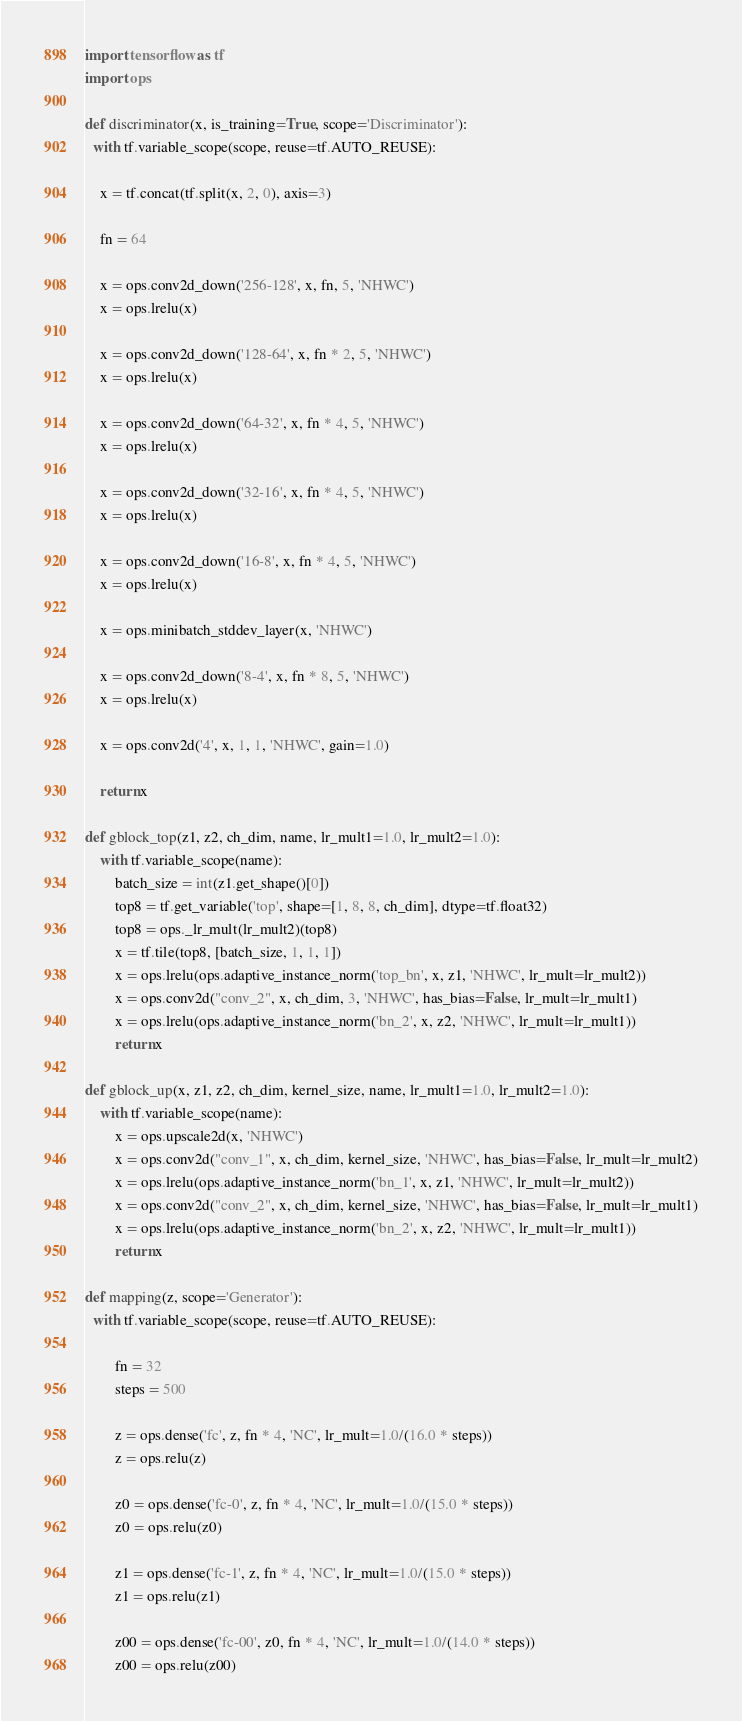Convert code to text. <code><loc_0><loc_0><loc_500><loc_500><_Python_>import tensorflow as tf
import ops

def discriminator(x, is_training=True, scope='Discriminator'):
  with tf.variable_scope(scope, reuse=tf.AUTO_REUSE):

    x = tf.concat(tf.split(x, 2, 0), axis=3)

    fn = 64    

    x = ops.conv2d_down('256-128', x, fn, 5, 'NHWC')
    x = ops.lrelu(x)

    x = ops.conv2d_down('128-64', x, fn * 2, 5, 'NHWC')
    x = ops.lrelu(x)

    x = ops.conv2d_down('64-32', x, fn * 4, 5, 'NHWC')
    x = ops.lrelu(x)

    x = ops.conv2d_down('32-16', x, fn * 4, 5, 'NHWC')
    x = ops.lrelu(x)

    x = ops.conv2d_down('16-8', x, fn * 4, 5, 'NHWC')
    x = ops.lrelu(x)
    
    x = ops.minibatch_stddev_layer(x, 'NHWC')

    x = ops.conv2d_down('8-4', x, fn * 8, 5, 'NHWC')
    x = ops.lrelu(x)

    x = ops.conv2d('4', x, 1, 1, 'NHWC', gain=1.0)

    return x

def gblock_top(z1, z2, ch_dim, name, lr_mult1=1.0, lr_mult2=1.0):
    with tf.variable_scope(name):
        batch_size = int(z1.get_shape()[0])
        top8 = tf.get_variable('top', shape=[1, 8, 8, ch_dim], dtype=tf.float32)
        top8 = ops._lr_mult(lr_mult2)(top8)
        x = tf.tile(top8, [batch_size, 1, 1, 1])
        x = ops.lrelu(ops.adaptive_instance_norm('top_bn', x, z1, 'NHWC', lr_mult=lr_mult2))        
        x = ops.conv2d("conv_2", x, ch_dim, 3, 'NHWC', has_bias=False, lr_mult=lr_mult1)
        x = ops.lrelu(ops.adaptive_instance_norm('bn_2', x, z2, 'NHWC', lr_mult=lr_mult1))        
        return x

def gblock_up(x, z1, z2, ch_dim, kernel_size, name, lr_mult1=1.0, lr_mult2=1.0):
    with tf.variable_scope(name):                
        x = ops.upscale2d(x, 'NHWC')
        x = ops.conv2d("conv_1", x, ch_dim, kernel_size, 'NHWC', has_bias=False, lr_mult=lr_mult2)
        x = ops.lrelu(ops.adaptive_instance_norm('bn_1', x, z1, 'NHWC', lr_mult=lr_mult2))        
        x = ops.conv2d("conv_2", x, ch_dim, kernel_size, 'NHWC', has_bias=False, lr_mult=lr_mult1)
        x = ops.lrelu(ops.adaptive_instance_norm('bn_2', x, z2, 'NHWC', lr_mult=lr_mult1))
        return x

def mapping(z, scope='Generator'):
  with tf.variable_scope(scope, reuse=tf.AUTO_REUSE):        
  
        fn = 32
        steps = 500

        z = ops.dense('fc', z, fn * 4, 'NC', lr_mult=1.0/(16.0 * steps))        
        z = ops.relu(z)
        
        z0 = ops.dense('fc-0', z, fn * 4, 'NC', lr_mult=1.0/(15.0 * steps))        
        z0 = ops.relu(z0)

        z1 = ops.dense('fc-1', z, fn * 4, 'NC', lr_mult=1.0/(15.0 * steps))        
        z1 = ops.relu(z1)

        z00 = ops.dense('fc-00', z0, fn * 4, 'NC', lr_mult=1.0/(14.0 * steps))        
        z00 = ops.relu(z00)
</code> 